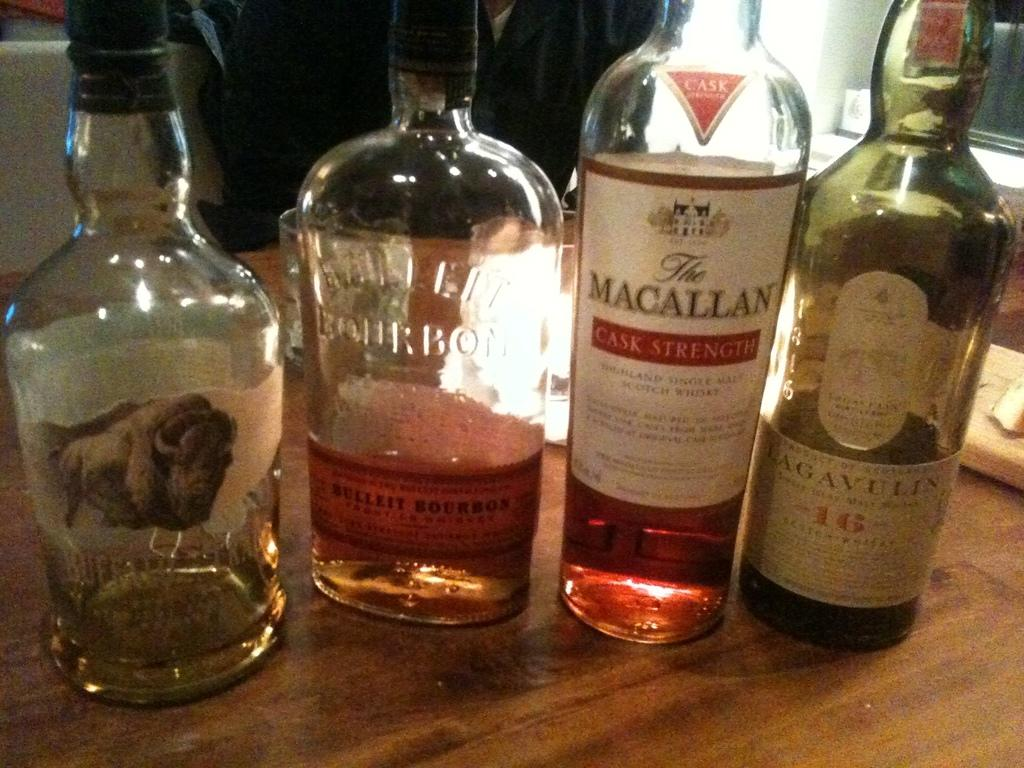<image>
Describe the image concisely. A bottle of Macallan is on a wooden table with some other bottles. 